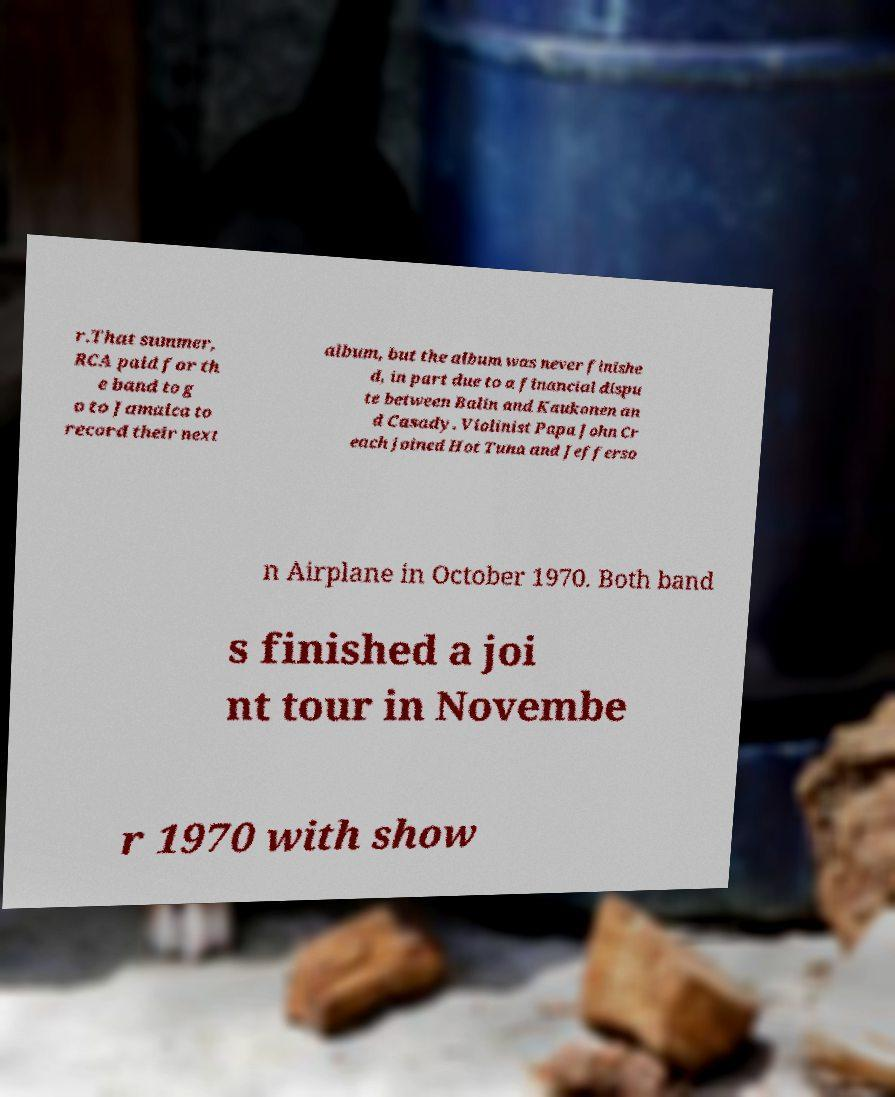For documentation purposes, I need the text within this image transcribed. Could you provide that? r.That summer, RCA paid for th e band to g o to Jamaica to record their next album, but the album was never finishe d, in part due to a financial dispu te between Balin and Kaukonen an d Casady. Violinist Papa John Cr each joined Hot Tuna and Jefferso n Airplane in October 1970. Both band s finished a joi nt tour in Novembe r 1970 with show 